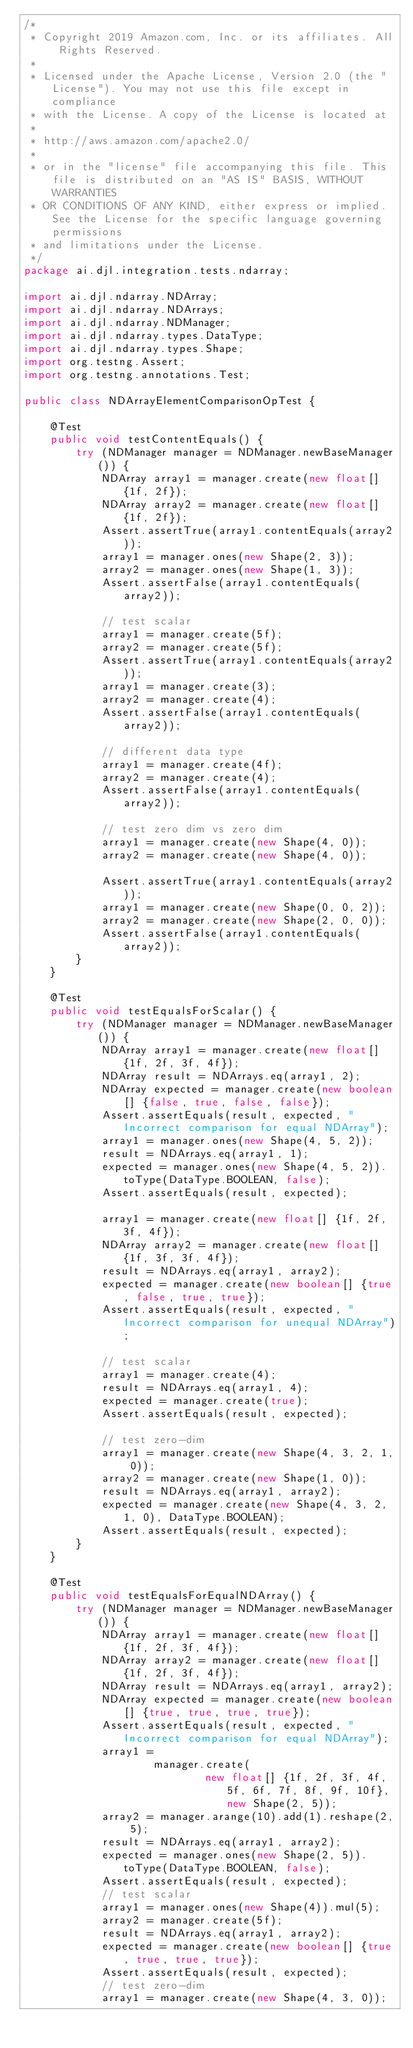Convert code to text. <code><loc_0><loc_0><loc_500><loc_500><_Java_>/*
 * Copyright 2019 Amazon.com, Inc. or its affiliates. All Rights Reserved.
 *
 * Licensed under the Apache License, Version 2.0 (the "License"). You may not use this file except in compliance
 * with the License. A copy of the License is located at
 *
 * http://aws.amazon.com/apache2.0/
 *
 * or in the "license" file accompanying this file. This file is distributed on an "AS IS" BASIS, WITHOUT WARRANTIES
 * OR CONDITIONS OF ANY KIND, either express or implied. See the License for the specific language governing permissions
 * and limitations under the License.
 */
package ai.djl.integration.tests.ndarray;

import ai.djl.ndarray.NDArray;
import ai.djl.ndarray.NDArrays;
import ai.djl.ndarray.NDManager;
import ai.djl.ndarray.types.DataType;
import ai.djl.ndarray.types.Shape;
import org.testng.Assert;
import org.testng.annotations.Test;

public class NDArrayElementComparisonOpTest {

    @Test
    public void testContentEquals() {
        try (NDManager manager = NDManager.newBaseManager()) {
            NDArray array1 = manager.create(new float[] {1f, 2f});
            NDArray array2 = manager.create(new float[] {1f, 2f});
            Assert.assertTrue(array1.contentEquals(array2));
            array1 = manager.ones(new Shape(2, 3));
            array2 = manager.ones(new Shape(1, 3));
            Assert.assertFalse(array1.contentEquals(array2));

            // test scalar
            array1 = manager.create(5f);
            array2 = manager.create(5f);
            Assert.assertTrue(array1.contentEquals(array2));
            array1 = manager.create(3);
            array2 = manager.create(4);
            Assert.assertFalse(array1.contentEquals(array2));

            // different data type
            array1 = manager.create(4f);
            array2 = manager.create(4);
            Assert.assertFalse(array1.contentEquals(array2));

            // test zero dim vs zero dim
            array1 = manager.create(new Shape(4, 0));
            array2 = manager.create(new Shape(4, 0));

            Assert.assertTrue(array1.contentEquals(array2));
            array1 = manager.create(new Shape(0, 0, 2));
            array2 = manager.create(new Shape(2, 0, 0));
            Assert.assertFalse(array1.contentEquals(array2));
        }
    }

    @Test
    public void testEqualsForScalar() {
        try (NDManager manager = NDManager.newBaseManager()) {
            NDArray array1 = manager.create(new float[] {1f, 2f, 3f, 4f});
            NDArray result = NDArrays.eq(array1, 2);
            NDArray expected = manager.create(new boolean[] {false, true, false, false});
            Assert.assertEquals(result, expected, "Incorrect comparison for equal NDArray");
            array1 = manager.ones(new Shape(4, 5, 2));
            result = NDArrays.eq(array1, 1);
            expected = manager.ones(new Shape(4, 5, 2)).toType(DataType.BOOLEAN, false);
            Assert.assertEquals(result, expected);

            array1 = manager.create(new float[] {1f, 2f, 3f, 4f});
            NDArray array2 = manager.create(new float[] {1f, 3f, 3f, 4f});
            result = NDArrays.eq(array1, array2);
            expected = manager.create(new boolean[] {true, false, true, true});
            Assert.assertEquals(result, expected, "Incorrect comparison for unequal NDArray");

            // test scalar
            array1 = manager.create(4);
            result = NDArrays.eq(array1, 4);
            expected = manager.create(true);
            Assert.assertEquals(result, expected);

            // test zero-dim
            array1 = manager.create(new Shape(4, 3, 2, 1, 0));
            array2 = manager.create(new Shape(1, 0));
            result = NDArrays.eq(array1, array2);
            expected = manager.create(new Shape(4, 3, 2, 1, 0), DataType.BOOLEAN);
            Assert.assertEquals(result, expected);
        }
    }

    @Test
    public void testEqualsForEqualNDArray() {
        try (NDManager manager = NDManager.newBaseManager()) {
            NDArray array1 = manager.create(new float[] {1f, 2f, 3f, 4f});
            NDArray array2 = manager.create(new float[] {1f, 2f, 3f, 4f});
            NDArray result = NDArrays.eq(array1, array2);
            NDArray expected = manager.create(new boolean[] {true, true, true, true});
            Assert.assertEquals(result, expected, "Incorrect comparison for equal NDArray");
            array1 =
                    manager.create(
                            new float[] {1f, 2f, 3f, 4f, 5f, 6f, 7f, 8f, 9f, 10f}, new Shape(2, 5));
            array2 = manager.arange(10).add(1).reshape(2, 5);
            result = NDArrays.eq(array1, array2);
            expected = manager.ones(new Shape(2, 5)).toType(DataType.BOOLEAN, false);
            Assert.assertEquals(result, expected);
            // test scalar
            array1 = manager.ones(new Shape(4)).mul(5);
            array2 = manager.create(5f);
            result = NDArrays.eq(array1, array2);
            expected = manager.create(new boolean[] {true, true, true, true});
            Assert.assertEquals(result, expected);
            // test zero-dim
            array1 = manager.create(new Shape(4, 3, 0));</code> 